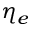Convert formula to latex. <formula><loc_0><loc_0><loc_500><loc_500>\eta _ { e }</formula> 